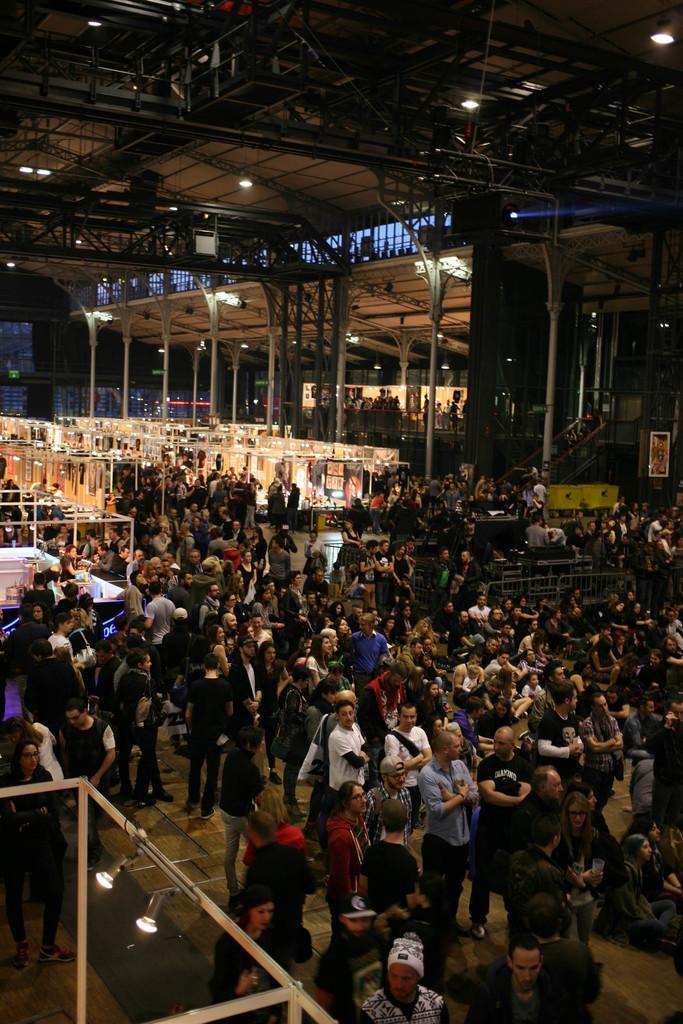Can you describe this image briefly? In this image, I can see groups of people standing and groups of people sitting on the floor. I can see stalls, barricades, lights and iron poles. At the top of the image, I can see iron trusses. 